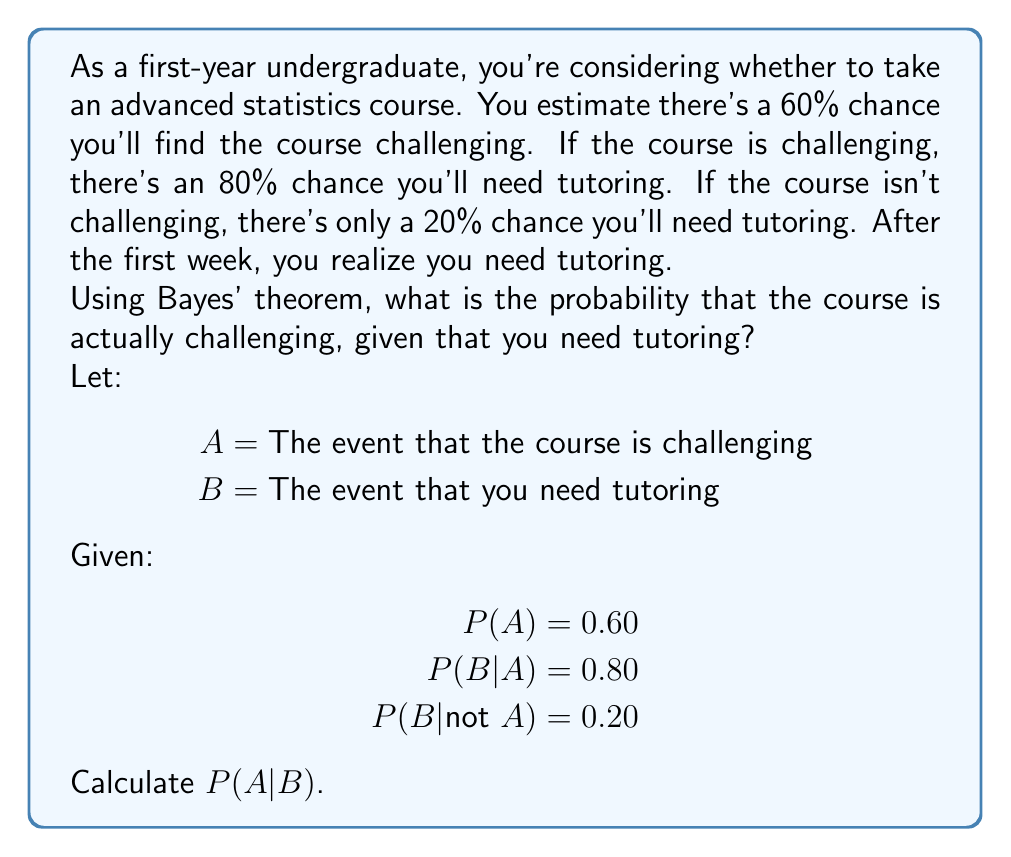Give your solution to this math problem. To solve this problem, we'll use Bayes' theorem:

$$P(A|B) = \frac{P(B|A) \cdot P(A)}{P(B)}$$

We're given P(B|A), P(A), and P(B|not A). We need to calculate P(B) using the law of total probability:

$$P(B) = P(B|A) \cdot P(A) + P(B|not A) \cdot P(not A)$$

Step 1: Calculate P(not A)
P(not A) = 1 - P(A) = 1 - 0.60 = 0.40

Step 2: Calculate P(B)
$$P(B) = 0.80 \cdot 0.60 + 0.20 \cdot 0.40 = 0.48 + 0.08 = 0.56$$

Step 3: Apply Bayes' theorem
$$P(A|B) = \frac{0.80 \cdot 0.60}{0.56} = \frac{0.48}{0.56} = \frac{6}{7} \approx 0.8571$$

Therefore, given that you need tutoring, the probability that the course is challenging is approximately 0.8571 or about 85.71%.
Answer: $\frac{6}{7}$ or approximately 0.8571 (85.71%) 